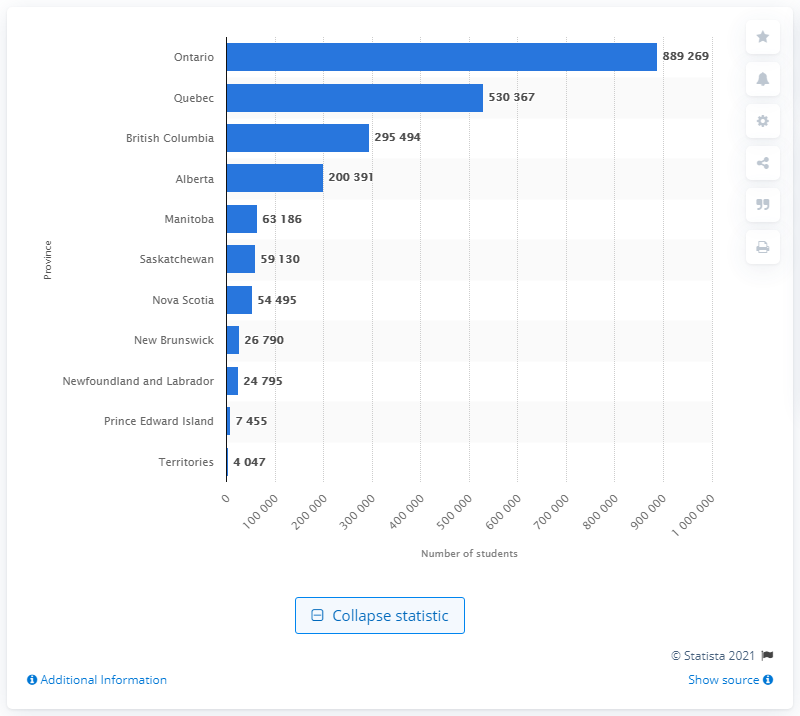List a handful of essential elements in this visual. In 2019, a total of 889,269 students were enrolled in postsecondary institutions in Ontario, which is the largest province in Canada in terms of population. 